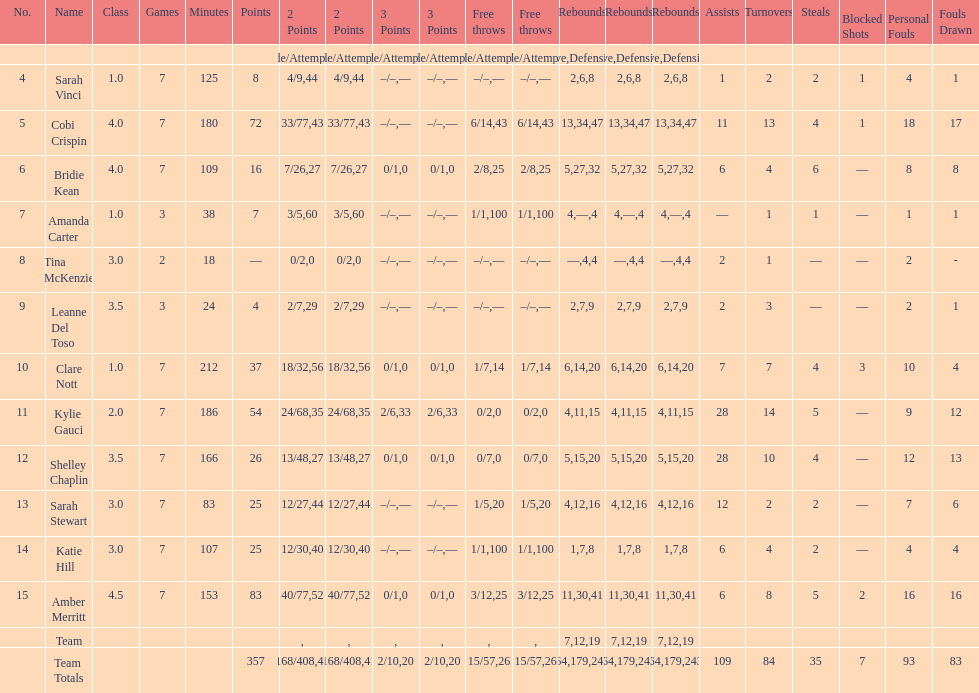Who is the last player on the list to not attempt a 3 point shot? Katie Hill. 